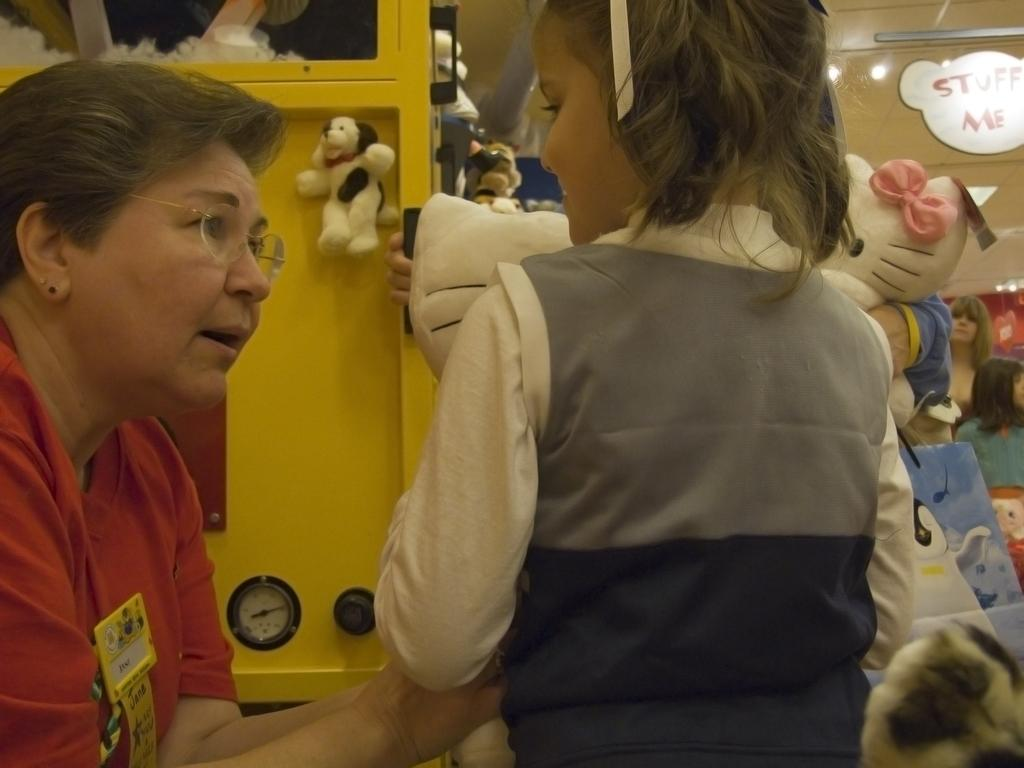Who is the person on the right side of the image? The facts provided do not give any information about the person's identity. What is the relationship between the person and the child in the image? The facts provided do not give any information about their relationship. What type of toys are in the image? The facts provided do not specify the type of toys in the image. What is the metal object on the left side of the image? The facts provided do not describe the metal object in detail. What is the name of the comb used by the child in the image? There is no comb present in the image. What type of treatment is the child receiving in the image? There is no indication of any treatment being administered in the image. 